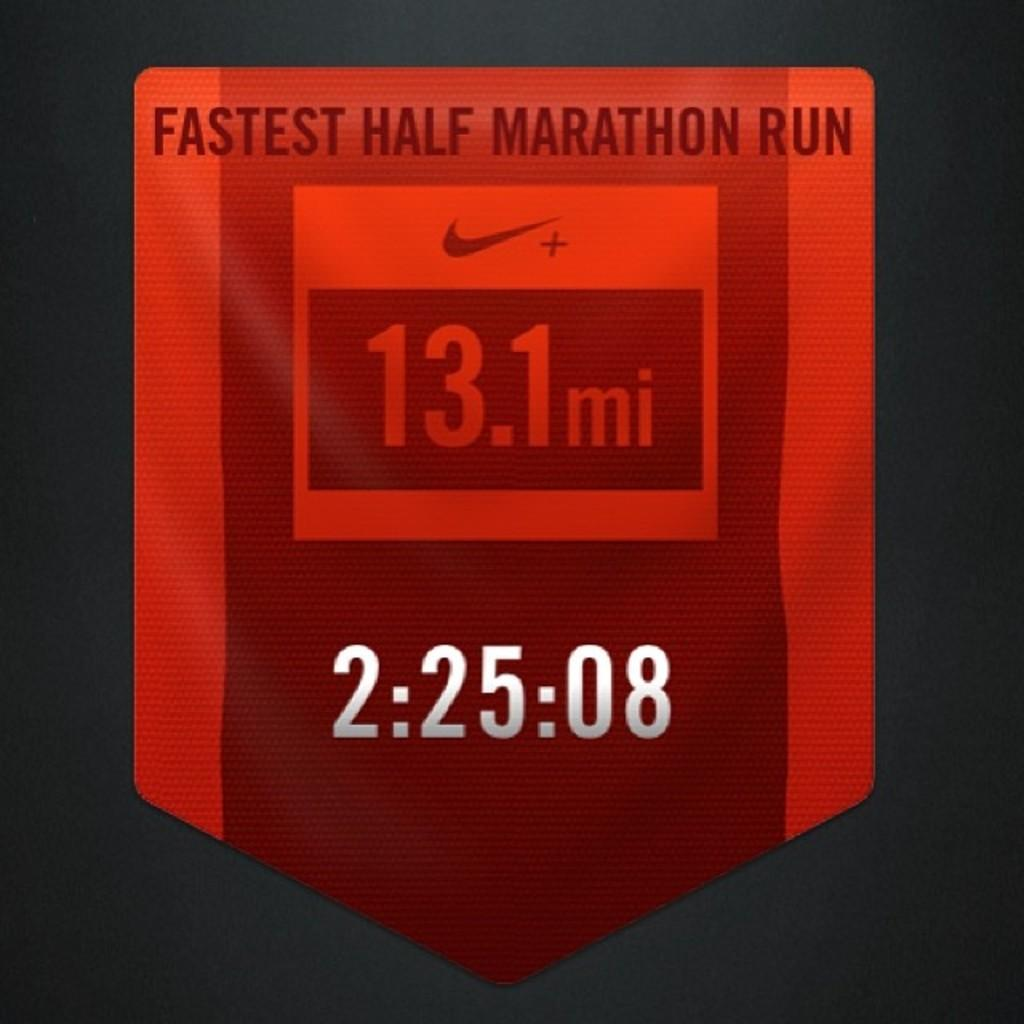Provide a one-sentence caption for the provided image. Red symbol showing the fastest half marathon run which was at 13.1 mi. 